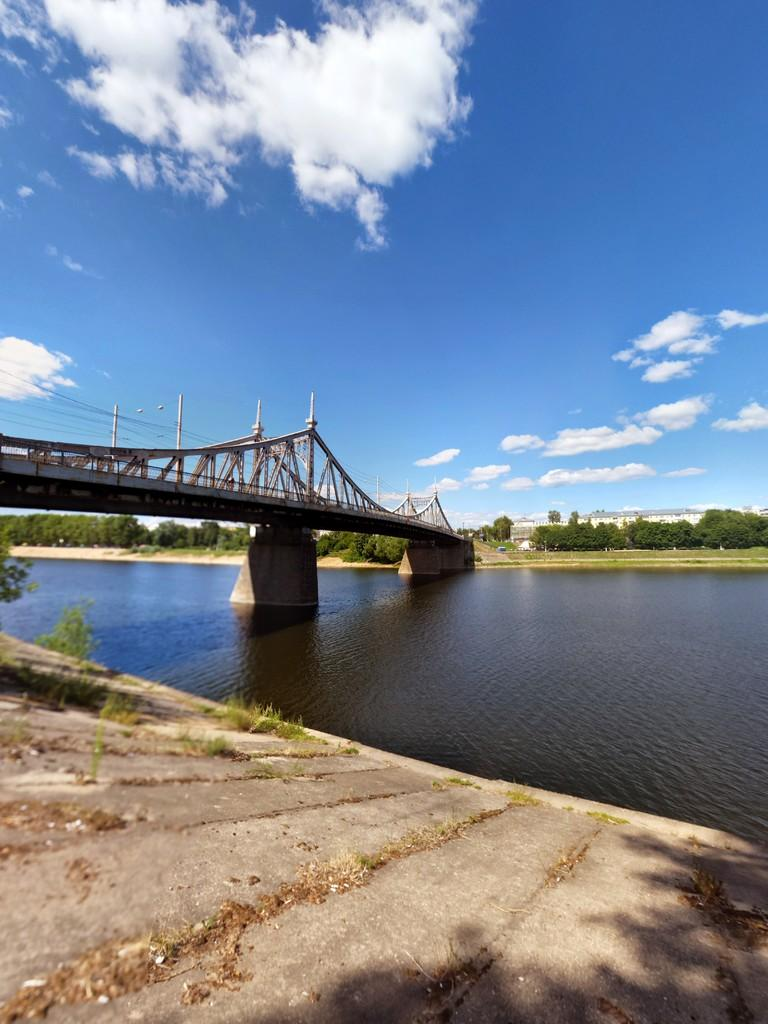What is the main subject of the image? The main subject of the image is a bridge. Can you describe the location of the bridge? The bridge is over water. What can be seen in the background of the image? There are trees, buildings, and the sky visible in the background of the image. What is the condition of the sky in the image? The sky is visible in the background of the image, and there are clouds present. What type of frame is used to hold the wine in the image? There is no wine or frame present in the image; it features a bridge over water with a background of trees, buildings, and the sky. 